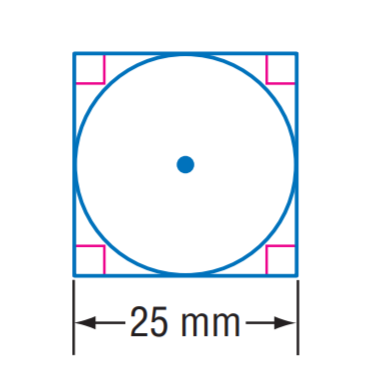Question: The square is circumscribed to the circle. Find the exact circumference of the circle.
Choices:
A. 12.5 \pi
B. 25 \pi
C. 30 \pi
D. 50 \pi
Answer with the letter. Answer: B 